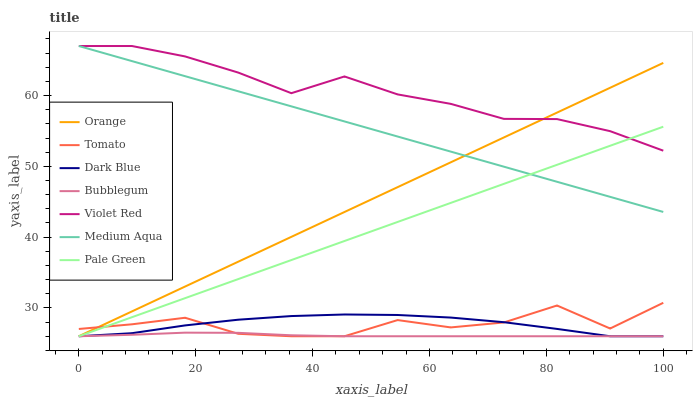Does Bubblegum have the minimum area under the curve?
Answer yes or no. Yes. Does Violet Red have the maximum area under the curve?
Answer yes or no. Yes. Does Violet Red have the minimum area under the curve?
Answer yes or no. No. Does Bubblegum have the maximum area under the curve?
Answer yes or no. No. Is Pale Green the smoothest?
Answer yes or no. Yes. Is Tomato the roughest?
Answer yes or no. Yes. Is Violet Red the smoothest?
Answer yes or no. No. Is Violet Red the roughest?
Answer yes or no. No. Does Tomato have the lowest value?
Answer yes or no. Yes. Does Violet Red have the lowest value?
Answer yes or no. No. Does Medium Aqua have the highest value?
Answer yes or no. Yes. Does Bubblegum have the highest value?
Answer yes or no. No. Is Dark Blue less than Medium Aqua?
Answer yes or no. Yes. Is Violet Red greater than Tomato?
Answer yes or no. Yes. Does Pale Green intersect Medium Aqua?
Answer yes or no. Yes. Is Pale Green less than Medium Aqua?
Answer yes or no. No. Is Pale Green greater than Medium Aqua?
Answer yes or no. No. Does Dark Blue intersect Medium Aqua?
Answer yes or no. No. 